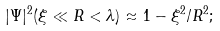Convert formula to latex. <formula><loc_0><loc_0><loc_500><loc_500>| \Psi | ^ { 2 } ( \xi \ll R < \lambda ) \approx 1 - \xi ^ { 2 } / R ^ { 2 } ;</formula> 